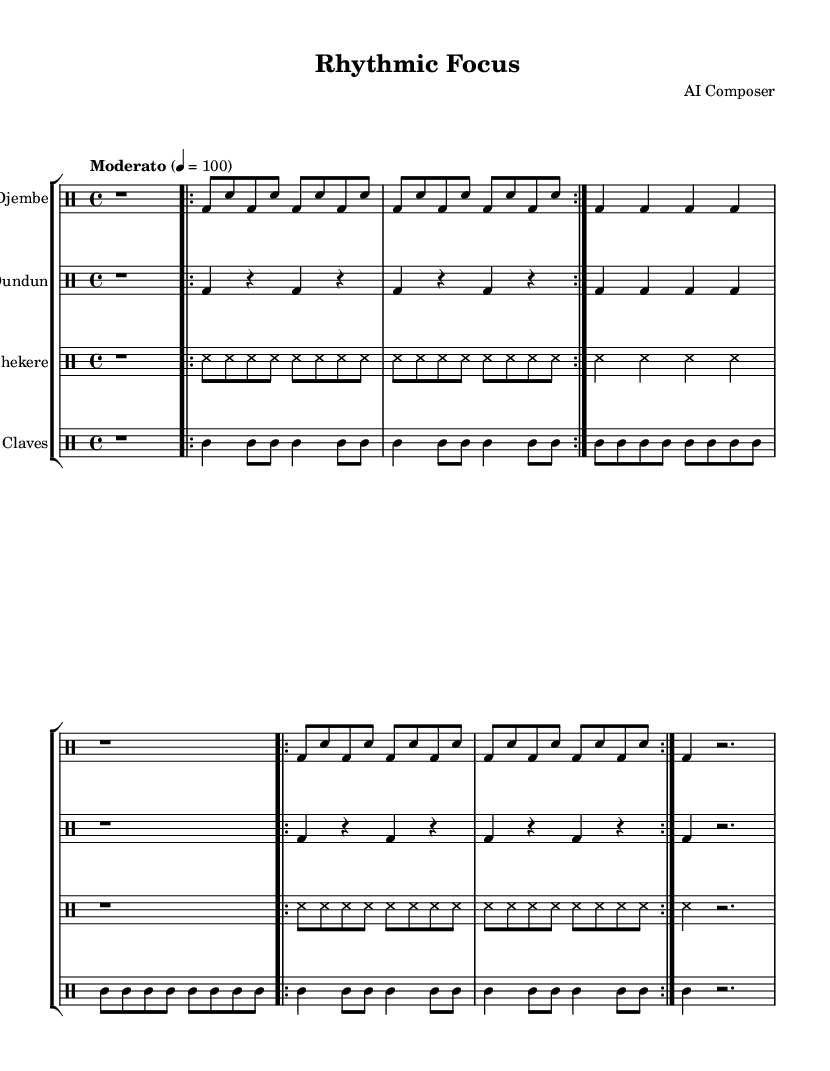What is the time signature of this music? The time signature is shown at the beginning of the score, which indicates how many beats are in each measure and which note value gets the beat. Here it is notated as 4/4, meaning there are four beats per measure and a quarter note receives one beat.
Answer: 4/4 What is the tempo marking for the piece? The tempo marking is indicated in the score, defining the speed of the music. It is marked as "Moderato" with a tempo indication of 100 quarter notes per minute.
Answer: Moderato 100 How many different drum parts are included in this composition? To find this, we look at the number of drum staves created in the score. There are four distinct drum parts: Djembe, Dundun, Shekere, and Claves, each represented by a separate staff.
Answer: Four What is the function of the 'break' sections in African drum music? The break sections in African drum music often allow for a pause or a moment of silence, creating a contrast with the rhythmic patterns. In this piece, the break sections provide a space to reset the rhythmic flow before repeating the main pattern.
Answer: Contrast and reset How many times is the main drum pattern repeated in the score? We first identify the main pattern in each drum part and note how many times it is indicated for repetition. In the sheet music, the main pattern is repeated two times, as indicated by the "repeat volta" markings.
Answer: Two times What rhythmic pattern do the claves play compared to the djembe? By comparing the rhythmic figures in the clave's section to those in the djembe's section, we can see that the claves utilize a combination of quarter and eighth notes, creating a syncopated rhythm that complements the djembe’s bass and snare pattern.
Answer: Syncopated rhythm 